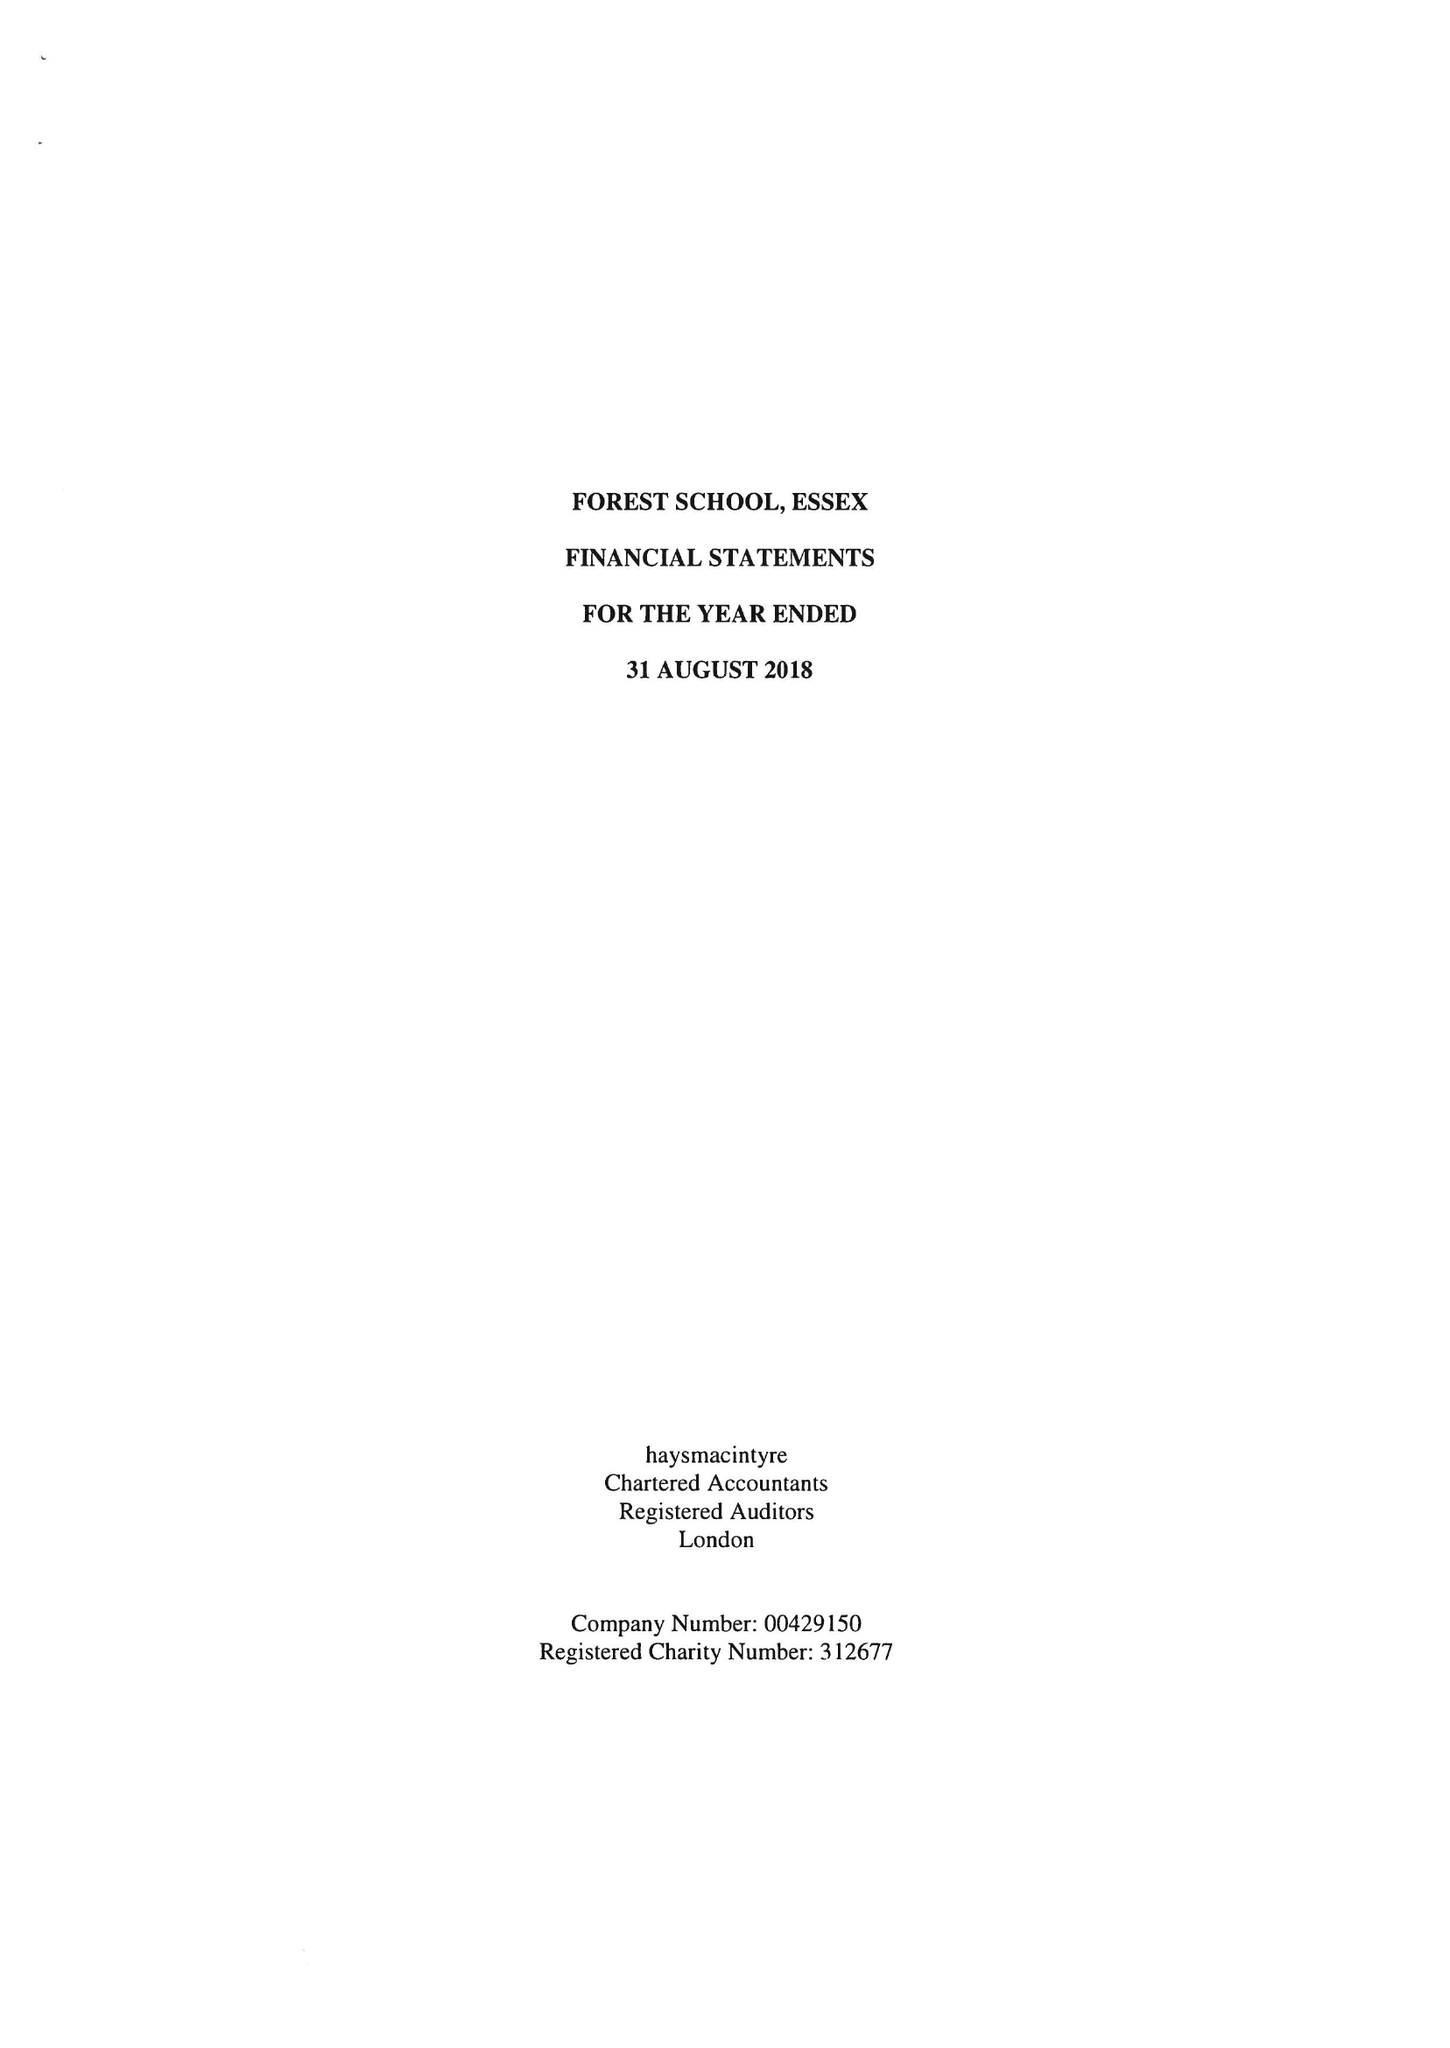What is the value for the charity_name?
Answer the question using a single word or phrase. Forest School, Essex 